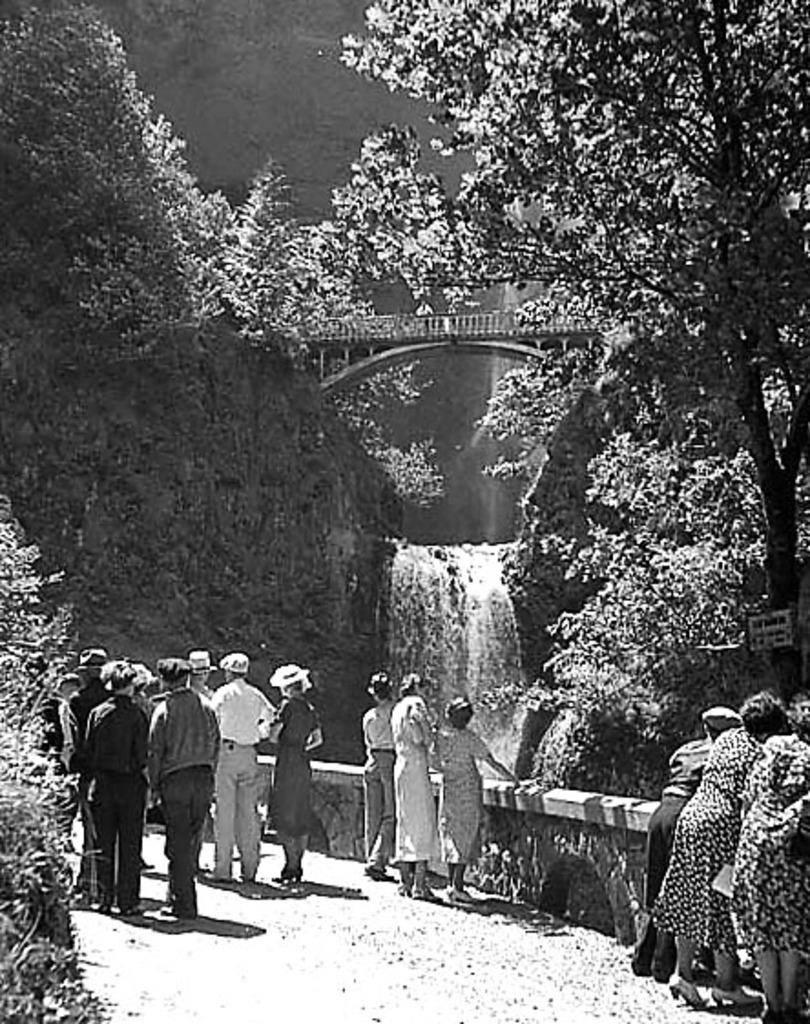What is the color scheme of the image? The image is black and white. What type of natural elements can be seen in the image? There are trees and waterfalls in the image. What man-made structure is present in the image? There is a bridge in the image. Where are the people located in the image? The people are standing on a path near a wall in the image. What type of cord is being used by the friend in the image? There is no friend or cord present in the image. What kind of stamp can be seen on the waterfall in the image? There is no stamp on the waterfall in the image; it is a natural feature. 